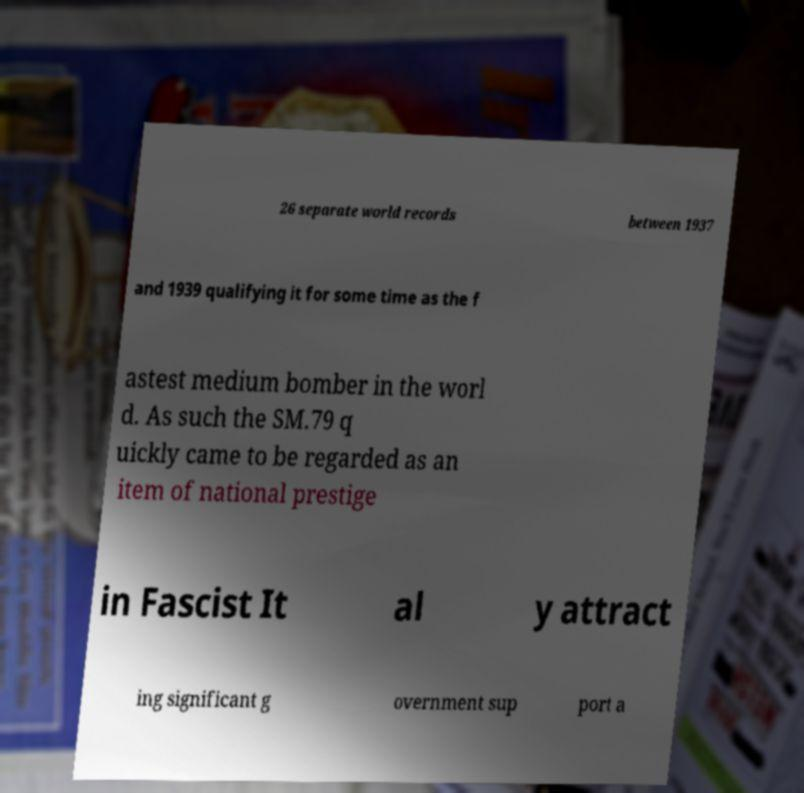Could you extract and type out the text from this image? 26 separate world records between 1937 and 1939 qualifying it for some time as the f astest medium bomber in the worl d. As such the SM.79 q uickly came to be regarded as an item of national prestige in Fascist It al y attract ing significant g overnment sup port a 